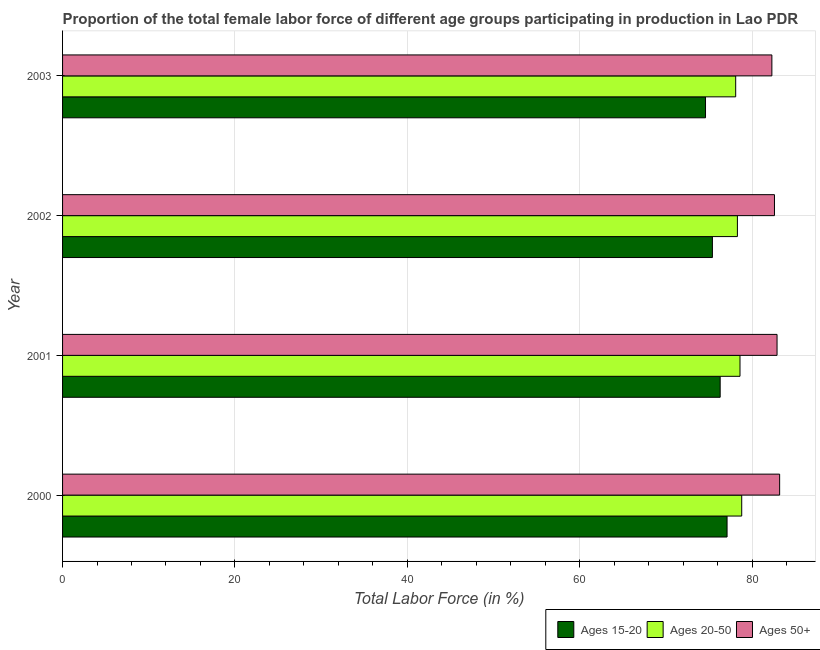How many groups of bars are there?
Ensure brevity in your answer.  4. Are the number of bars on each tick of the Y-axis equal?
Provide a short and direct response. Yes. How many bars are there on the 2nd tick from the top?
Your answer should be very brief. 3. What is the label of the 4th group of bars from the top?
Provide a short and direct response. 2000. What is the percentage of female labor force above age 50 in 2003?
Your answer should be very brief. 82.3. Across all years, what is the maximum percentage of female labor force above age 50?
Offer a very short reply. 83.2. Across all years, what is the minimum percentage of female labor force within the age group 15-20?
Offer a very short reply. 74.6. In which year was the percentage of female labor force above age 50 maximum?
Your answer should be compact. 2000. In which year was the percentage of female labor force above age 50 minimum?
Keep it short and to the point. 2003. What is the total percentage of female labor force above age 50 in the graph?
Your answer should be very brief. 331. What is the difference between the percentage of female labor force above age 50 in 2000 and the percentage of female labor force within the age group 20-50 in 2002?
Offer a very short reply. 4.9. What is the average percentage of female labor force within the age group 15-20 per year?
Offer a terse response. 75.85. In the year 2001, what is the difference between the percentage of female labor force within the age group 20-50 and percentage of female labor force above age 50?
Offer a very short reply. -4.3. What is the ratio of the percentage of female labor force within the age group 20-50 in 2000 to that in 2001?
Provide a succinct answer. 1. Is the percentage of female labor force above age 50 in 2001 less than that in 2003?
Provide a succinct answer. No. Is the difference between the percentage of female labor force within the age group 15-20 in 2002 and 2003 greater than the difference between the percentage of female labor force within the age group 20-50 in 2002 and 2003?
Your answer should be very brief. Yes. What is the difference between the highest and the second highest percentage of female labor force above age 50?
Offer a very short reply. 0.3. What is the difference between the highest and the lowest percentage of female labor force within the age group 15-20?
Offer a terse response. 2.5. What does the 1st bar from the top in 2003 represents?
Provide a short and direct response. Ages 50+. What does the 3rd bar from the bottom in 2003 represents?
Your answer should be very brief. Ages 50+. How many bars are there?
Your answer should be very brief. 12. What is the difference between two consecutive major ticks on the X-axis?
Ensure brevity in your answer.  20. Are the values on the major ticks of X-axis written in scientific E-notation?
Keep it short and to the point. No. How are the legend labels stacked?
Ensure brevity in your answer.  Horizontal. What is the title of the graph?
Your answer should be very brief. Proportion of the total female labor force of different age groups participating in production in Lao PDR. Does "Transport services" appear as one of the legend labels in the graph?
Keep it short and to the point. No. What is the label or title of the X-axis?
Give a very brief answer. Total Labor Force (in %). What is the label or title of the Y-axis?
Provide a short and direct response. Year. What is the Total Labor Force (in %) of Ages 15-20 in 2000?
Keep it short and to the point. 77.1. What is the Total Labor Force (in %) of Ages 20-50 in 2000?
Provide a succinct answer. 78.8. What is the Total Labor Force (in %) of Ages 50+ in 2000?
Provide a short and direct response. 83.2. What is the Total Labor Force (in %) of Ages 15-20 in 2001?
Keep it short and to the point. 76.3. What is the Total Labor Force (in %) in Ages 20-50 in 2001?
Your answer should be compact. 78.6. What is the Total Labor Force (in %) of Ages 50+ in 2001?
Ensure brevity in your answer.  82.9. What is the Total Labor Force (in %) of Ages 15-20 in 2002?
Offer a terse response. 75.4. What is the Total Labor Force (in %) in Ages 20-50 in 2002?
Provide a short and direct response. 78.3. What is the Total Labor Force (in %) of Ages 50+ in 2002?
Ensure brevity in your answer.  82.6. What is the Total Labor Force (in %) of Ages 15-20 in 2003?
Your answer should be very brief. 74.6. What is the Total Labor Force (in %) of Ages 20-50 in 2003?
Keep it short and to the point. 78.1. What is the Total Labor Force (in %) in Ages 50+ in 2003?
Make the answer very short. 82.3. Across all years, what is the maximum Total Labor Force (in %) of Ages 15-20?
Ensure brevity in your answer.  77.1. Across all years, what is the maximum Total Labor Force (in %) in Ages 20-50?
Give a very brief answer. 78.8. Across all years, what is the maximum Total Labor Force (in %) of Ages 50+?
Make the answer very short. 83.2. Across all years, what is the minimum Total Labor Force (in %) of Ages 15-20?
Keep it short and to the point. 74.6. Across all years, what is the minimum Total Labor Force (in %) in Ages 20-50?
Give a very brief answer. 78.1. Across all years, what is the minimum Total Labor Force (in %) in Ages 50+?
Offer a very short reply. 82.3. What is the total Total Labor Force (in %) in Ages 15-20 in the graph?
Your response must be concise. 303.4. What is the total Total Labor Force (in %) of Ages 20-50 in the graph?
Make the answer very short. 313.8. What is the total Total Labor Force (in %) in Ages 50+ in the graph?
Offer a terse response. 331. What is the difference between the Total Labor Force (in %) of Ages 15-20 in 2000 and that in 2001?
Your response must be concise. 0.8. What is the difference between the Total Labor Force (in %) in Ages 20-50 in 2000 and that in 2001?
Make the answer very short. 0.2. What is the difference between the Total Labor Force (in %) of Ages 50+ in 2000 and that in 2001?
Your response must be concise. 0.3. What is the difference between the Total Labor Force (in %) in Ages 50+ in 2000 and that in 2003?
Your answer should be very brief. 0.9. What is the difference between the Total Labor Force (in %) of Ages 15-20 in 2001 and that in 2002?
Provide a short and direct response. 0.9. What is the difference between the Total Labor Force (in %) in Ages 50+ in 2001 and that in 2002?
Provide a short and direct response. 0.3. What is the difference between the Total Labor Force (in %) in Ages 20-50 in 2001 and that in 2003?
Make the answer very short. 0.5. What is the difference between the Total Labor Force (in %) in Ages 15-20 in 2002 and that in 2003?
Give a very brief answer. 0.8. What is the difference between the Total Labor Force (in %) in Ages 20-50 in 2002 and that in 2003?
Your answer should be compact. 0.2. What is the difference between the Total Labor Force (in %) of Ages 15-20 in 2000 and the Total Labor Force (in %) of Ages 20-50 in 2001?
Provide a succinct answer. -1.5. What is the difference between the Total Labor Force (in %) of Ages 15-20 in 2000 and the Total Labor Force (in %) of Ages 50+ in 2001?
Ensure brevity in your answer.  -5.8. What is the difference between the Total Labor Force (in %) of Ages 20-50 in 2000 and the Total Labor Force (in %) of Ages 50+ in 2001?
Offer a very short reply. -4.1. What is the difference between the Total Labor Force (in %) of Ages 15-20 in 2000 and the Total Labor Force (in %) of Ages 20-50 in 2002?
Provide a short and direct response. -1.2. What is the difference between the Total Labor Force (in %) of Ages 15-20 in 2000 and the Total Labor Force (in %) of Ages 50+ in 2002?
Your answer should be very brief. -5.5. What is the difference between the Total Labor Force (in %) in Ages 20-50 in 2000 and the Total Labor Force (in %) in Ages 50+ in 2003?
Make the answer very short. -3.5. What is the difference between the Total Labor Force (in %) of Ages 15-20 in 2001 and the Total Labor Force (in %) of Ages 20-50 in 2002?
Your answer should be compact. -2. What is the difference between the Total Labor Force (in %) of Ages 20-50 in 2001 and the Total Labor Force (in %) of Ages 50+ in 2002?
Ensure brevity in your answer.  -4. What is the difference between the Total Labor Force (in %) in Ages 15-20 in 2001 and the Total Labor Force (in %) in Ages 20-50 in 2003?
Provide a short and direct response. -1.8. What is the difference between the Total Labor Force (in %) in Ages 15-20 in 2002 and the Total Labor Force (in %) in Ages 20-50 in 2003?
Your answer should be compact. -2.7. What is the difference between the Total Labor Force (in %) of Ages 15-20 in 2002 and the Total Labor Force (in %) of Ages 50+ in 2003?
Make the answer very short. -6.9. What is the difference between the Total Labor Force (in %) of Ages 20-50 in 2002 and the Total Labor Force (in %) of Ages 50+ in 2003?
Provide a short and direct response. -4. What is the average Total Labor Force (in %) of Ages 15-20 per year?
Provide a succinct answer. 75.85. What is the average Total Labor Force (in %) of Ages 20-50 per year?
Your answer should be very brief. 78.45. What is the average Total Labor Force (in %) of Ages 50+ per year?
Offer a terse response. 82.75. In the year 2000, what is the difference between the Total Labor Force (in %) of Ages 20-50 and Total Labor Force (in %) of Ages 50+?
Provide a short and direct response. -4.4. In the year 2001, what is the difference between the Total Labor Force (in %) in Ages 15-20 and Total Labor Force (in %) in Ages 50+?
Provide a short and direct response. -6.6. In the year 2001, what is the difference between the Total Labor Force (in %) in Ages 20-50 and Total Labor Force (in %) in Ages 50+?
Ensure brevity in your answer.  -4.3. In the year 2002, what is the difference between the Total Labor Force (in %) in Ages 15-20 and Total Labor Force (in %) in Ages 50+?
Provide a succinct answer. -7.2. In the year 2003, what is the difference between the Total Labor Force (in %) of Ages 15-20 and Total Labor Force (in %) of Ages 20-50?
Keep it short and to the point. -3.5. In the year 2003, what is the difference between the Total Labor Force (in %) in Ages 20-50 and Total Labor Force (in %) in Ages 50+?
Your answer should be very brief. -4.2. What is the ratio of the Total Labor Force (in %) of Ages 15-20 in 2000 to that in 2001?
Your answer should be very brief. 1.01. What is the ratio of the Total Labor Force (in %) in Ages 20-50 in 2000 to that in 2001?
Your answer should be very brief. 1. What is the ratio of the Total Labor Force (in %) of Ages 50+ in 2000 to that in 2001?
Provide a short and direct response. 1. What is the ratio of the Total Labor Force (in %) in Ages 15-20 in 2000 to that in 2002?
Your answer should be very brief. 1.02. What is the ratio of the Total Labor Force (in %) in Ages 20-50 in 2000 to that in 2002?
Offer a very short reply. 1.01. What is the ratio of the Total Labor Force (in %) in Ages 50+ in 2000 to that in 2002?
Make the answer very short. 1.01. What is the ratio of the Total Labor Force (in %) in Ages 15-20 in 2000 to that in 2003?
Provide a succinct answer. 1.03. What is the ratio of the Total Labor Force (in %) of Ages 20-50 in 2000 to that in 2003?
Make the answer very short. 1.01. What is the ratio of the Total Labor Force (in %) of Ages 50+ in 2000 to that in 2003?
Provide a short and direct response. 1.01. What is the ratio of the Total Labor Force (in %) in Ages 15-20 in 2001 to that in 2002?
Ensure brevity in your answer.  1.01. What is the ratio of the Total Labor Force (in %) of Ages 50+ in 2001 to that in 2002?
Your answer should be very brief. 1. What is the ratio of the Total Labor Force (in %) of Ages 15-20 in 2001 to that in 2003?
Give a very brief answer. 1.02. What is the ratio of the Total Labor Force (in %) of Ages 20-50 in 2001 to that in 2003?
Your answer should be very brief. 1.01. What is the ratio of the Total Labor Force (in %) in Ages 50+ in 2001 to that in 2003?
Your response must be concise. 1.01. What is the ratio of the Total Labor Force (in %) of Ages 15-20 in 2002 to that in 2003?
Your response must be concise. 1.01. What is the ratio of the Total Labor Force (in %) of Ages 20-50 in 2002 to that in 2003?
Your answer should be compact. 1. What is the ratio of the Total Labor Force (in %) of Ages 50+ in 2002 to that in 2003?
Offer a very short reply. 1. What is the difference between the highest and the second highest Total Labor Force (in %) in Ages 15-20?
Offer a terse response. 0.8. What is the difference between the highest and the second highest Total Labor Force (in %) of Ages 20-50?
Offer a terse response. 0.2. What is the difference between the highest and the second highest Total Labor Force (in %) in Ages 50+?
Make the answer very short. 0.3. What is the difference between the highest and the lowest Total Labor Force (in %) in Ages 20-50?
Your answer should be compact. 0.7. 